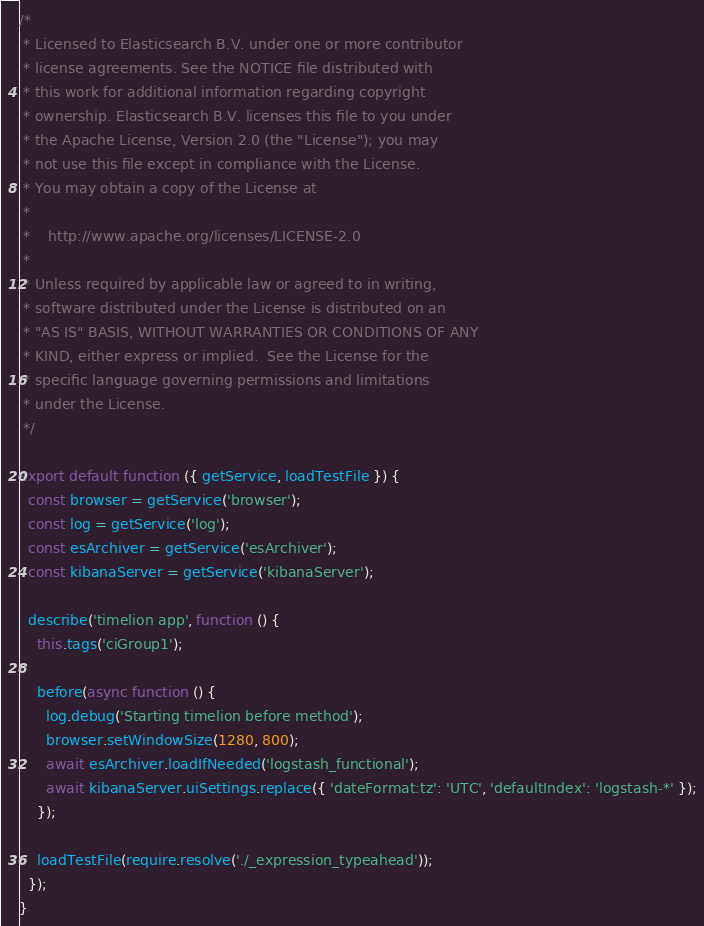<code> <loc_0><loc_0><loc_500><loc_500><_JavaScript_>/*
 * Licensed to Elasticsearch B.V. under one or more contributor
 * license agreements. See the NOTICE file distributed with
 * this work for additional information regarding copyright
 * ownership. Elasticsearch B.V. licenses this file to you under
 * the Apache License, Version 2.0 (the "License"); you may
 * not use this file except in compliance with the License.
 * You may obtain a copy of the License at
 *
 *    http://www.apache.org/licenses/LICENSE-2.0
 *
 * Unless required by applicable law or agreed to in writing,
 * software distributed under the License is distributed on an
 * "AS IS" BASIS, WITHOUT WARRANTIES OR CONDITIONS OF ANY
 * KIND, either express or implied.  See the License for the
 * specific language governing permissions and limitations
 * under the License.
 */

export default function ({ getService, loadTestFile }) {
  const browser = getService('browser');
  const log = getService('log');
  const esArchiver = getService('esArchiver');
  const kibanaServer = getService('kibanaServer');

  describe('timelion app', function () {
    this.tags('ciGroup1');

    before(async function () {
      log.debug('Starting timelion before method');
      browser.setWindowSize(1280, 800);
      await esArchiver.loadIfNeeded('logstash_functional');
      await kibanaServer.uiSettings.replace({ 'dateFormat:tz': 'UTC', 'defaultIndex': 'logstash-*' });
    });

    loadTestFile(require.resolve('./_expression_typeahead'));
  });
}
</code> 